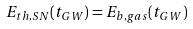Convert formula to latex. <formula><loc_0><loc_0><loc_500><loc_500>E _ { t h , S N } ( t _ { G W } ) = E _ { b , g a s } ( t _ { G W } )</formula> 